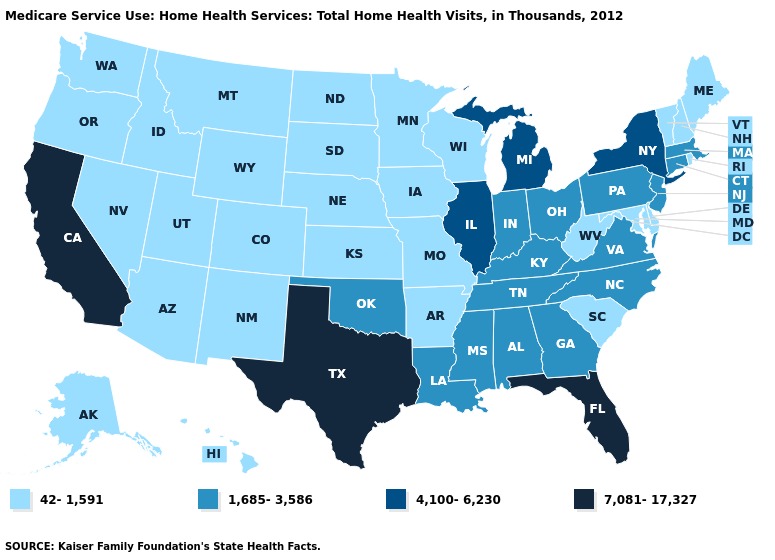Does New York have the lowest value in the Northeast?
Short answer required. No. What is the lowest value in the MidWest?
Be succinct. 42-1,591. Does Florida have the highest value in the USA?
Short answer required. Yes. Name the states that have a value in the range 7,081-17,327?
Keep it brief. California, Florida, Texas. What is the lowest value in states that border New Mexico?
Be succinct. 42-1,591. What is the value of Connecticut?
Be succinct. 1,685-3,586. Does Delaware have a lower value than West Virginia?
Give a very brief answer. No. Does Utah have the lowest value in the USA?
Give a very brief answer. Yes. Name the states that have a value in the range 4,100-6,230?
Short answer required. Illinois, Michigan, New York. What is the highest value in the USA?
Write a very short answer. 7,081-17,327. Among the states that border Texas , which have the lowest value?
Short answer required. Arkansas, New Mexico. What is the lowest value in states that border Virginia?
Quick response, please. 42-1,591. Does Oklahoma have the same value as Pennsylvania?
Concise answer only. Yes. Does New Jersey have a higher value than Missouri?
Be succinct. Yes. Name the states that have a value in the range 4,100-6,230?
Quick response, please. Illinois, Michigan, New York. 